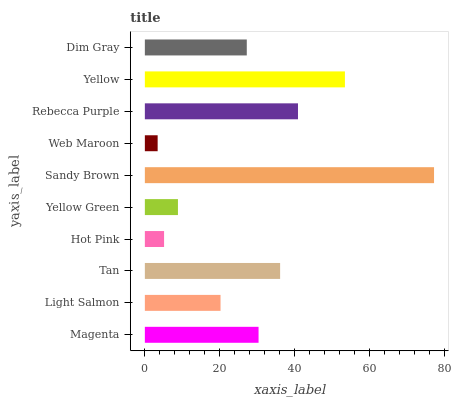Is Web Maroon the minimum?
Answer yes or no. Yes. Is Sandy Brown the maximum?
Answer yes or no. Yes. Is Light Salmon the minimum?
Answer yes or no. No. Is Light Salmon the maximum?
Answer yes or no. No. Is Magenta greater than Light Salmon?
Answer yes or no. Yes. Is Light Salmon less than Magenta?
Answer yes or no. Yes. Is Light Salmon greater than Magenta?
Answer yes or no. No. Is Magenta less than Light Salmon?
Answer yes or no. No. Is Magenta the high median?
Answer yes or no. Yes. Is Dim Gray the low median?
Answer yes or no. Yes. Is Yellow the high median?
Answer yes or no. No. Is Web Maroon the low median?
Answer yes or no. No. 